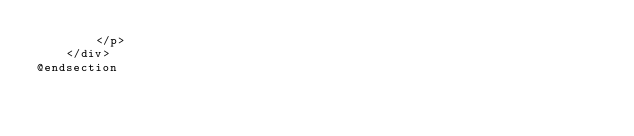Convert code to text. <code><loc_0><loc_0><loc_500><loc_500><_PHP_>        </p>
    </div>
@endsection
</code> 